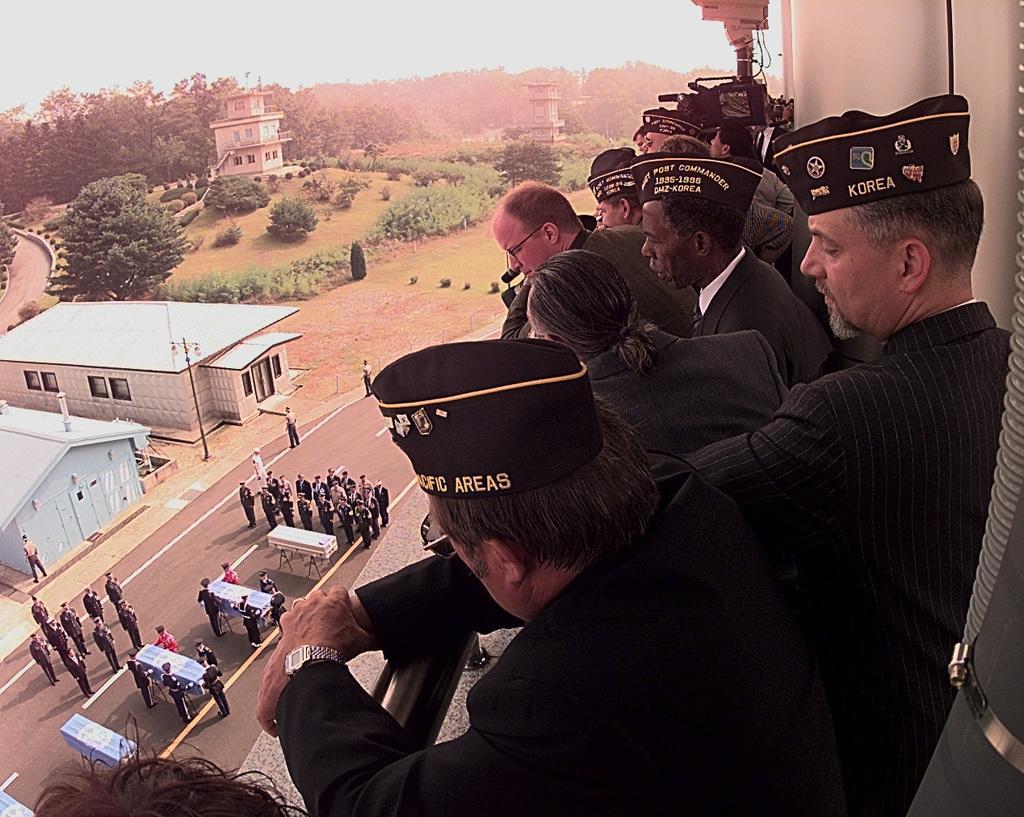Could you give a brief overview of what you see in this image? On the right side, there are persons. Some of them are wearing black color caps. Beside them, there is a fence. On the left side, there are boxes arranged, there are persons standing on the road and there are buildings. In the background, there are buildings, trees, plants and grass on the ground and there is sky. 